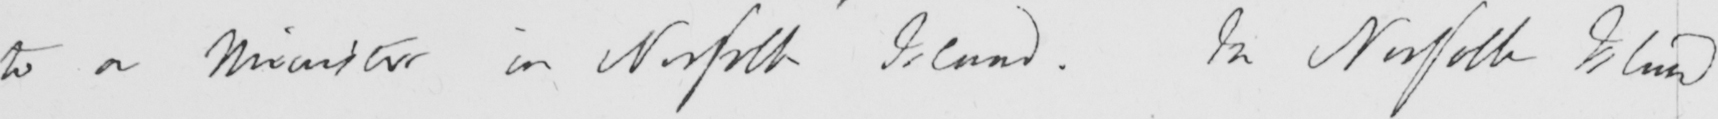Can you read and transcribe this handwriting? to be a Minister in Norfolk Island . In Norfolk Island 